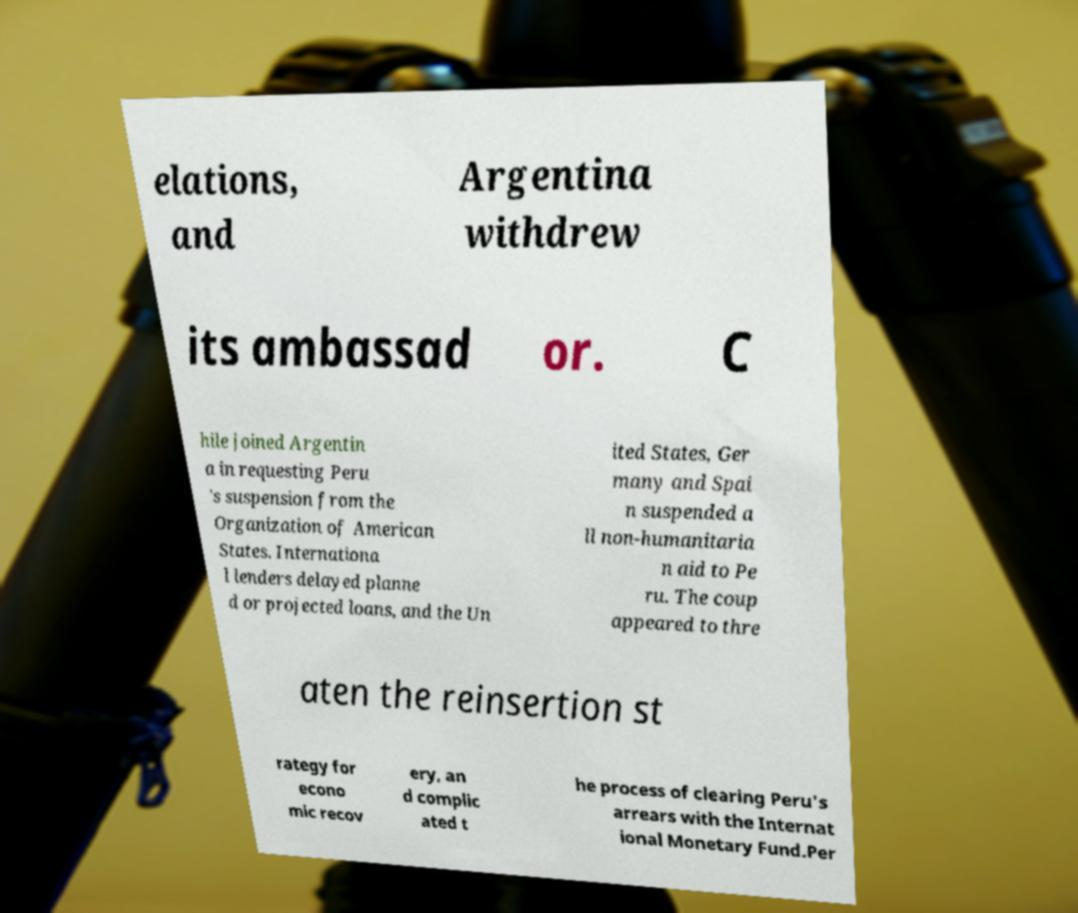Could you extract and type out the text from this image? elations, and Argentina withdrew its ambassad or. C hile joined Argentin a in requesting Peru 's suspension from the Organization of American States. Internationa l lenders delayed planne d or projected loans, and the Un ited States, Ger many and Spai n suspended a ll non-humanitaria n aid to Pe ru. The coup appeared to thre aten the reinsertion st rategy for econo mic recov ery, an d complic ated t he process of clearing Peru's arrears with the Internat ional Monetary Fund.Per 